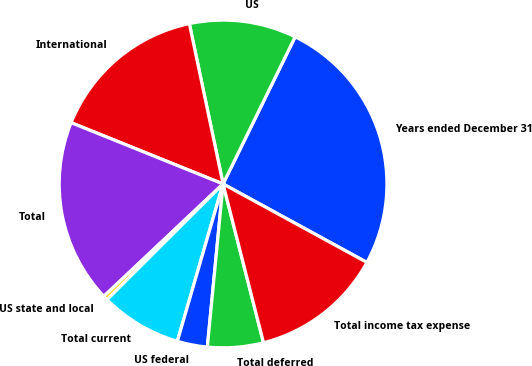Convert chart. <chart><loc_0><loc_0><loc_500><loc_500><pie_chart><fcel>Years ended December 31<fcel>US<fcel>International<fcel>Total<fcel>US state and local<fcel>Total current<fcel>US federal<fcel>Total deferred<fcel>Total income tax expense<nl><fcel>25.7%<fcel>10.55%<fcel>15.6%<fcel>18.13%<fcel>0.45%<fcel>8.02%<fcel>2.97%<fcel>5.5%<fcel>13.08%<nl></chart> 